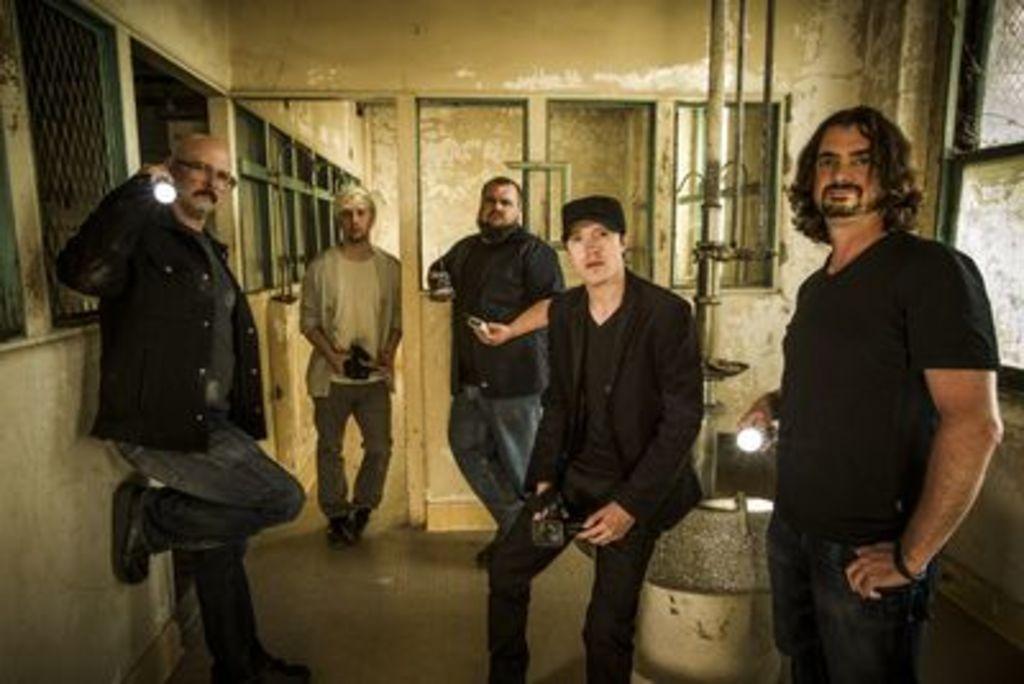Please provide a concise description of this image. In this image we can see a few people holding the objects, there are some windows and a pole, also we can see the wall. 